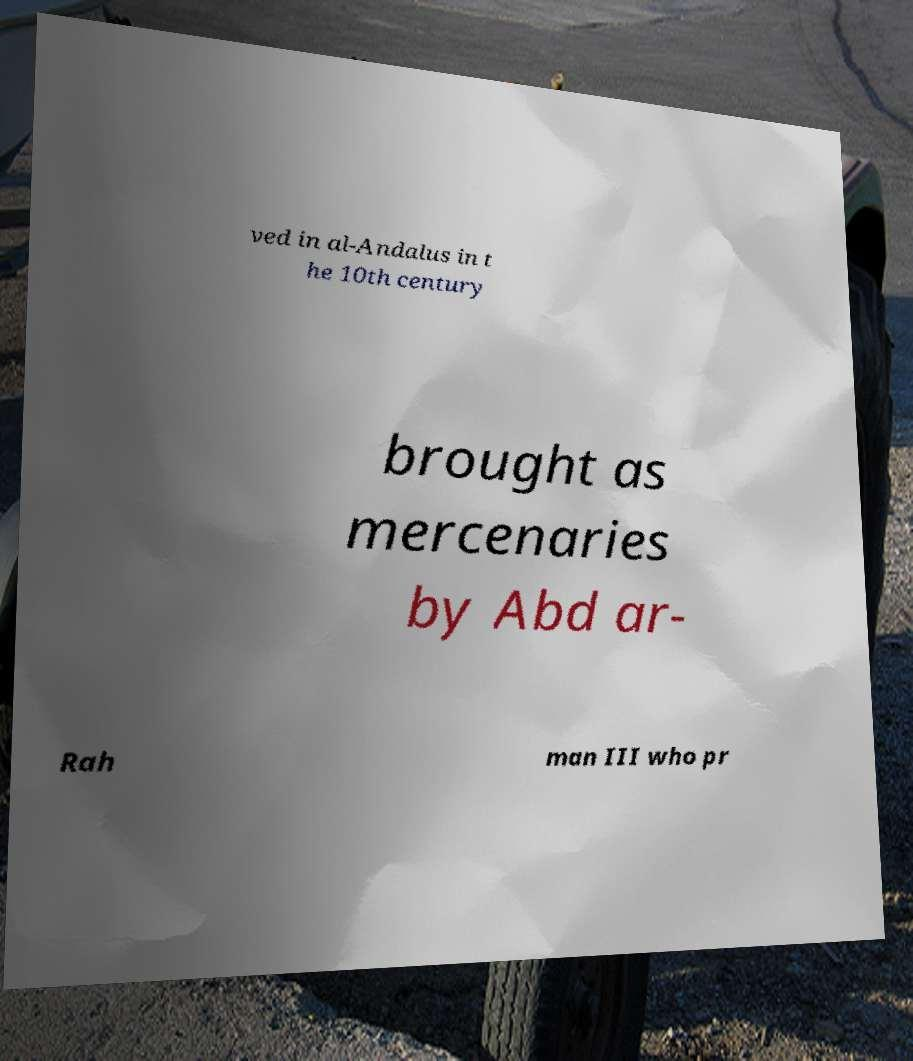Could you assist in decoding the text presented in this image and type it out clearly? ved in al-Andalus in t he 10th century brought as mercenaries by Abd ar- Rah man III who pr 